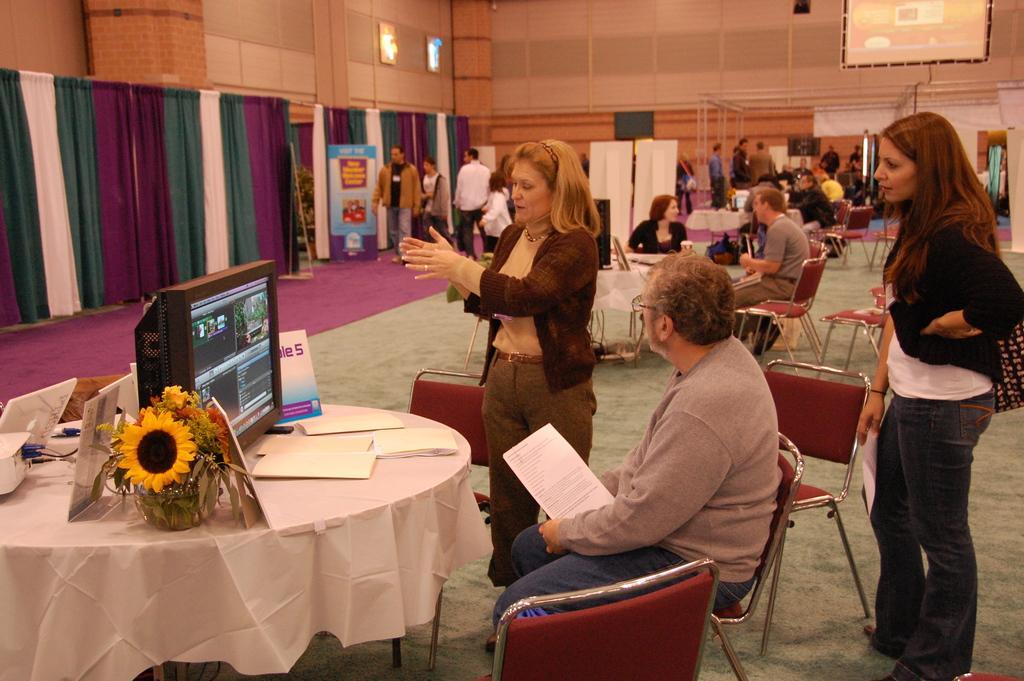Describe this image in one or two sentences. This a picture of a hall in which there are some round tables and chairs and people sitting on the chairs and standing in the hall. On the table we have a small plant, flowers, screen and some papers and around the room we have some colorful curtains and a big screen. 